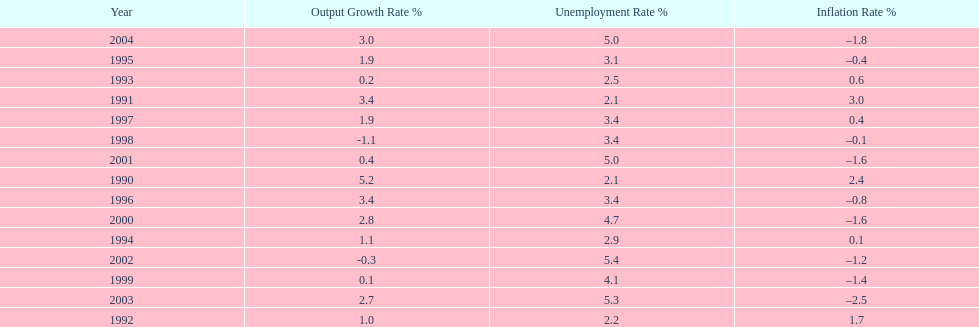Were the highest unemployment rates in japan before or after the year 2000? After. 